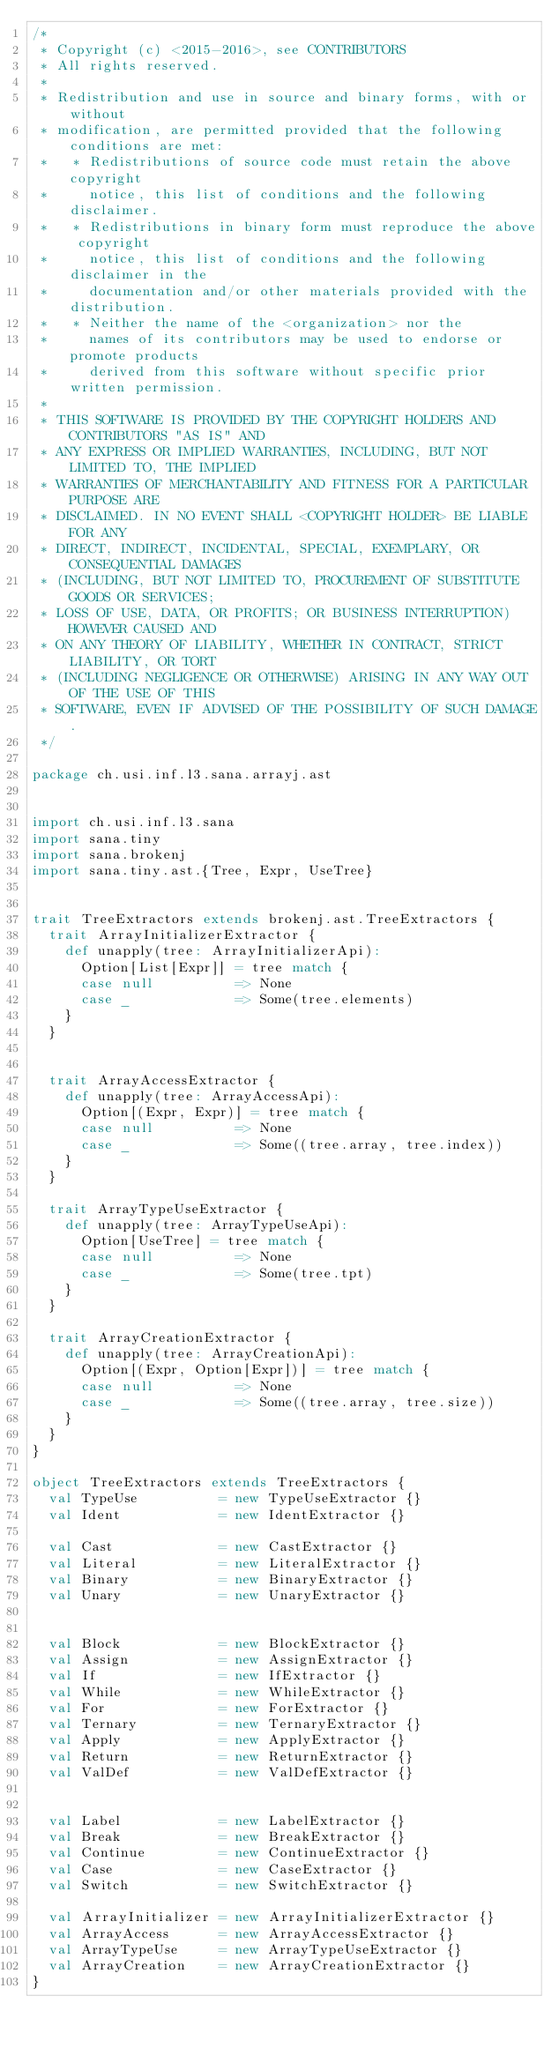<code> <loc_0><loc_0><loc_500><loc_500><_Scala_>/*
 * Copyright (c) <2015-2016>, see CONTRIBUTORS
 * All rights reserved.
 *
 * Redistribution and use in source and binary forms, with or without
 * modification, are permitted provided that the following conditions are met:
 *   * Redistributions of source code must retain the above copyright
 *     notice, this list of conditions and the following disclaimer.
 *   * Redistributions in binary form must reproduce the above copyright
 *     notice, this list of conditions and the following disclaimer in the
 *     documentation and/or other materials provided with the distribution.
 *   * Neither the name of the <organization> nor the
 *     names of its contributors may be used to endorse or promote products
 *     derived from this software without specific prior written permission.
 *
 * THIS SOFTWARE IS PROVIDED BY THE COPYRIGHT HOLDERS AND CONTRIBUTORS "AS IS" AND
 * ANY EXPRESS OR IMPLIED WARRANTIES, INCLUDING, BUT NOT LIMITED TO, THE IMPLIED
 * WARRANTIES OF MERCHANTABILITY AND FITNESS FOR A PARTICULAR PURPOSE ARE
 * DISCLAIMED. IN NO EVENT SHALL <COPYRIGHT HOLDER> BE LIABLE FOR ANY
 * DIRECT, INDIRECT, INCIDENTAL, SPECIAL, EXEMPLARY, OR CONSEQUENTIAL DAMAGES
 * (INCLUDING, BUT NOT LIMITED TO, PROCUREMENT OF SUBSTITUTE GOODS OR SERVICES;
 * LOSS OF USE, DATA, OR PROFITS; OR BUSINESS INTERRUPTION) HOWEVER CAUSED AND
 * ON ANY THEORY OF LIABILITY, WHETHER IN CONTRACT, STRICT LIABILITY, OR TORT
 * (INCLUDING NEGLIGENCE OR OTHERWISE) ARISING IN ANY WAY OUT OF THE USE OF THIS
 * SOFTWARE, EVEN IF ADVISED OF THE POSSIBILITY OF SUCH DAMAGE.
 */

package ch.usi.inf.l3.sana.arrayj.ast


import ch.usi.inf.l3.sana
import sana.tiny
import sana.brokenj
import sana.tiny.ast.{Tree, Expr, UseTree}


trait TreeExtractors extends brokenj.ast.TreeExtractors {
  trait ArrayInitializerExtractor {
    def unapply(tree: ArrayInitializerApi):
      Option[List[Expr]] = tree match {
      case null          => None
      case _             => Some(tree.elements)
    }
  }


  trait ArrayAccessExtractor {
    def unapply(tree: ArrayAccessApi):
      Option[(Expr, Expr)] = tree match {
      case null          => None
      case _             => Some((tree.array, tree.index))
    }
  }

  trait ArrayTypeUseExtractor {
    def unapply(tree: ArrayTypeUseApi):
      Option[UseTree] = tree match {
      case null          => None
      case _             => Some(tree.tpt)
    }
  }

  trait ArrayCreationExtractor {
    def unapply(tree: ArrayCreationApi):
      Option[(Expr, Option[Expr])] = tree match {
      case null          => None
      case _             => Some((tree.array, tree.size))
    }
  }
}

object TreeExtractors extends TreeExtractors {
  val TypeUse          = new TypeUseExtractor {}
  val Ident            = new IdentExtractor {}

  val Cast             = new CastExtractor {}
  val Literal          = new LiteralExtractor {}
  val Binary           = new BinaryExtractor {}
  val Unary            = new UnaryExtractor {}


  val Block            = new BlockExtractor {}
  val Assign           = new AssignExtractor {}
  val If               = new IfExtractor {}
  val While            = new WhileExtractor {}
  val For              = new ForExtractor {}
  val Ternary          = new TernaryExtractor {}
  val Apply            = new ApplyExtractor {}
  val Return           = new ReturnExtractor {}
  val ValDef           = new ValDefExtractor {}


  val Label            = new LabelExtractor {}
  val Break            = new BreakExtractor {}
  val Continue         = new ContinueExtractor {}
  val Case             = new CaseExtractor {}
  val Switch           = new SwitchExtractor {}

  val ArrayInitializer = new ArrayInitializerExtractor {}
  val ArrayAccess      = new ArrayAccessExtractor {}
  val ArrayTypeUse     = new ArrayTypeUseExtractor {}
  val ArrayCreation    = new ArrayCreationExtractor {}
}
</code> 